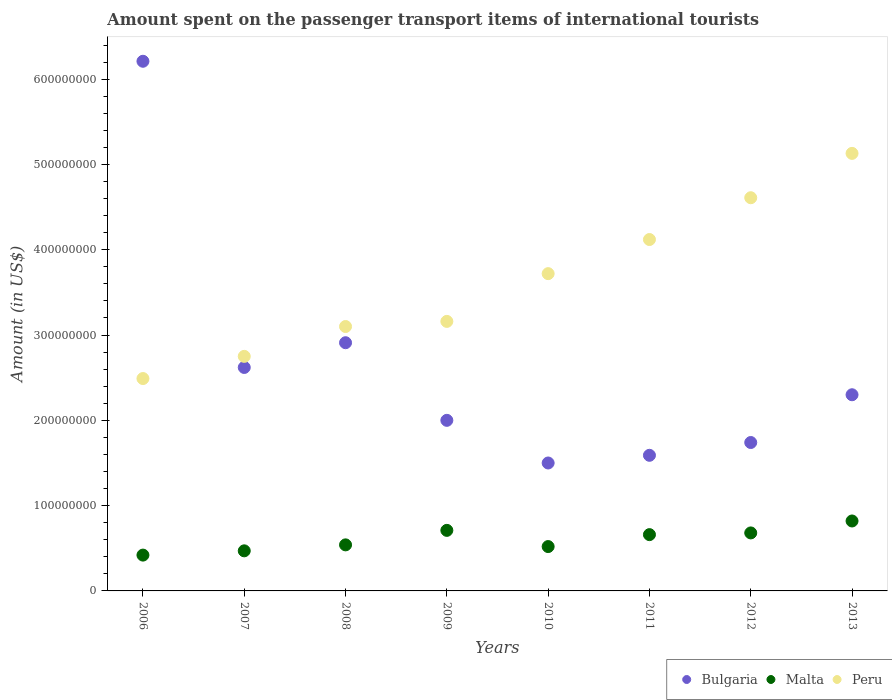How many different coloured dotlines are there?
Your answer should be very brief. 3. Is the number of dotlines equal to the number of legend labels?
Your response must be concise. Yes. What is the amount spent on the passenger transport items of international tourists in Malta in 2009?
Make the answer very short. 7.10e+07. Across all years, what is the maximum amount spent on the passenger transport items of international tourists in Bulgaria?
Give a very brief answer. 6.21e+08. Across all years, what is the minimum amount spent on the passenger transport items of international tourists in Bulgaria?
Offer a terse response. 1.50e+08. In which year was the amount spent on the passenger transport items of international tourists in Malta maximum?
Make the answer very short. 2013. In which year was the amount spent on the passenger transport items of international tourists in Bulgaria minimum?
Provide a succinct answer. 2010. What is the total amount spent on the passenger transport items of international tourists in Peru in the graph?
Provide a short and direct response. 2.91e+09. What is the difference between the amount spent on the passenger transport items of international tourists in Peru in 2007 and that in 2008?
Ensure brevity in your answer.  -3.50e+07. What is the difference between the amount spent on the passenger transport items of international tourists in Malta in 2009 and the amount spent on the passenger transport items of international tourists in Bulgaria in 2012?
Your response must be concise. -1.03e+08. What is the average amount spent on the passenger transport items of international tourists in Malta per year?
Give a very brief answer. 6.02e+07. In the year 2013, what is the difference between the amount spent on the passenger transport items of international tourists in Peru and amount spent on the passenger transport items of international tourists in Bulgaria?
Offer a very short reply. 2.83e+08. What is the ratio of the amount spent on the passenger transport items of international tourists in Peru in 2009 to that in 2013?
Provide a short and direct response. 0.62. Is the amount spent on the passenger transport items of international tourists in Malta in 2006 less than that in 2009?
Your answer should be very brief. Yes. Is the difference between the amount spent on the passenger transport items of international tourists in Peru in 2011 and 2012 greater than the difference between the amount spent on the passenger transport items of international tourists in Bulgaria in 2011 and 2012?
Your answer should be very brief. No. What is the difference between the highest and the second highest amount spent on the passenger transport items of international tourists in Bulgaria?
Your answer should be compact. 3.30e+08. What is the difference between the highest and the lowest amount spent on the passenger transport items of international tourists in Bulgaria?
Your answer should be very brief. 4.71e+08. Is the amount spent on the passenger transport items of international tourists in Malta strictly greater than the amount spent on the passenger transport items of international tourists in Peru over the years?
Your response must be concise. No. Is the amount spent on the passenger transport items of international tourists in Malta strictly less than the amount spent on the passenger transport items of international tourists in Bulgaria over the years?
Ensure brevity in your answer.  Yes. How many years are there in the graph?
Ensure brevity in your answer.  8. Are the values on the major ticks of Y-axis written in scientific E-notation?
Offer a very short reply. No. Does the graph contain any zero values?
Provide a succinct answer. No. Does the graph contain grids?
Offer a terse response. No. Where does the legend appear in the graph?
Your response must be concise. Bottom right. How are the legend labels stacked?
Provide a succinct answer. Horizontal. What is the title of the graph?
Ensure brevity in your answer.  Amount spent on the passenger transport items of international tourists. What is the label or title of the Y-axis?
Provide a short and direct response. Amount (in US$). What is the Amount (in US$) in Bulgaria in 2006?
Provide a succinct answer. 6.21e+08. What is the Amount (in US$) of Malta in 2006?
Provide a succinct answer. 4.20e+07. What is the Amount (in US$) in Peru in 2006?
Your answer should be compact. 2.49e+08. What is the Amount (in US$) in Bulgaria in 2007?
Keep it short and to the point. 2.62e+08. What is the Amount (in US$) in Malta in 2007?
Make the answer very short. 4.70e+07. What is the Amount (in US$) in Peru in 2007?
Provide a succinct answer. 2.75e+08. What is the Amount (in US$) of Bulgaria in 2008?
Your answer should be compact. 2.91e+08. What is the Amount (in US$) of Malta in 2008?
Give a very brief answer. 5.40e+07. What is the Amount (in US$) of Peru in 2008?
Your answer should be very brief. 3.10e+08. What is the Amount (in US$) in Malta in 2009?
Give a very brief answer. 7.10e+07. What is the Amount (in US$) of Peru in 2009?
Ensure brevity in your answer.  3.16e+08. What is the Amount (in US$) of Bulgaria in 2010?
Offer a terse response. 1.50e+08. What is the Amount (in US$) in Malta in 2010?
Offer a very short reply. 5.20e+07. What is the Amount (in US$) of Peru in 2010?
Provide a short and direct response. 3.72e+08. What is the Amount (in US$) in Bulgaria in 2011?
Keep it short and to the point. 1.59e+08. What is the Amount (in US$) of Malta in 2011?
Provide a short and direct response. 6.60e+07. What is the Amount (in US$) in Peru in 2011?
Offer a terse response. 4.12e+08. What is the Amount (in US$) in Bulgaria in 2012?
Provide a succinct answer. 1.74e+08. What is the Amount (in US$) of Malta in 2012?
Keep it short and to the point. 6.80e+07. What is the Amount (in US$) in Peru in 2012?
Provide a succinct answer. 4.61e+08. What is the Amount (in US$) of Bulgaria in 2013?
Keep it short and to the point. 2.30e+08. What is the Amount (in US$) in Malta in 2013?
Ensure brevity in your answer.  8.20e+07. What is the Amount (in US$) of Peru in 2013?
Your answer should be very brief. 5.13e+08. Across all years, what is the maximum Amount (in US$) of Bulgaria?
Keep it short and to the point. 6.21e+08. Across all years, what is the maximum Amount (in US$) of Malta?
Provide a short and direct response. 8.20e+07. Across all years, what is the maximum Amount (in US$) in Peru?
Ensure brevity in your answer.  5.13e+08. Across all years, what is the minimum Amount (in US$) in Bulgaria?
Make the answer very short. 1.50e+08. Across all years, what is the minimum Amount (in US$) of Malta?
Your answer should be compact. 4.20e+07. Across all years, what is the minimum Amount (in US$) of Peru?
Your response must be concise. 2.49e+08. What is the total Amount (in US$) of Bulgaria in the graph?
Offer a terse response. 2.09e+09. What is the total Amount (in US$) of Malta in the graph?
Offer a very short reply. 4.82e+08. What is the total Amount (in US$) in Peru in the graph?
Provide a short and direct response. 2.91e+09. What is the difference between the Amount (in US$) of Bulgaria in 2006 and that in 2007?
Offer a very short reply. 3.59e+08. What is the difference between the Amount (in US$) of Malta in 2006 and that in 2007?
Ensure brevity in your answer.  -5.00e+06. What is the difference between the Amount (in US$) of Peru in 2006 and that in 2007?
Give a very brief answer. -2.60e+07. What is the difference between the Amount (in US$) in Bulgaria in 2006 and that in 2008?
Make the answer very short. 3.30e+08. What is the difference between the Amount (in US$) in Malta in 2006 and that in 2008?
Make the answer very short. -1.20e+07. What is the difference between the Amount (in US$) in Peru in 2006 and that in 2008?
Ensure brevity in your answer.  -6.10e+07. What is the difference between the Amount (in US$) in Bulgaria in 2006 and that in 2009?
Provide a succinct answer. 4.21e+08. What is the difference between the Amount (in US$) in Malta in 2006 and that in 2009?
Keep it short and to the point. -2.90e+07. What is the difference between the Amount (in US$) in Peru in 2006 and that in 2009?
Your response must be concise. -6.70e+07. What is the difference between the Amount (in US$) in Bulgaria in 2006 and that in 2010?
Your answer should be very brief. 4.71e+08. What is the difference between the Amount (in US$) in Malta in 2006 and that in 2010?
Offer a very short reply. -1.00e+07. What is the difference between the Amount (in US$) of Peru in 2006 and that in 2010?
Provide a short and direct response. -1.23e+08. What is the difference between the Amount (in US$) in Bulgaria in 2006 and that in 2011?
Give a very brief answer. 4.62e+08. What is the difference between the Amount (in US$) of Malta in 2006 and that in 2011?
Keep it short and to the point. -2.40e+07. What is the difference between the Amount (in US$) of Peru in 2006 and that in 2011?
Offer a very short reply. -1.63e+08. What is the difference between the Amount (in US$) of Bulgaria in 2006 and that in 2012?
Offer a very short reply. 4.47e+08. What is the difference between the Amount (in US$) in Malta in 2006 and that in 2012?
Provide a succinct answer. -2.60e+07. What is the difference between the Amount (in US$) in Peru in 2006 and that in 2012?
Offer a terse response. -2.12e+08. What is the difference between the Amount (in US$) in Bulgaria in 2006 and that in 2013?
Keep it short and to the point. 3.91e+08. What is the difference between the Amount (in US$) in Malta in 2006 and that in 2013?
Your answer should be very brief. -4.00e+07. What is the difference between the Amount (in US$) of Peru in 2006 and that in 2013?
Provide a succinct answer. -2.64e+08. What is the difference between the Amount (in US$) of Bulgaria in 2007 and that in 2008?
Give a very brief answer. -2.90e+07. What is the difference between the Amount (in US$) in Malta in 2007 and that in 2008?
Your response must be concise. -7.00e+06. What is the difference between the Amount (in US$) of Peru in 2007 and that in 2008?
Make the answer very short. -3.50e+07. What is the difference between the Amount (in US$) of Bulgaria in 2007 and that in 2009?
Give a very brief answer. 6.20e+07. What is the difference between the Amount (in US$) of Malta in 2007 and that in 2009?
Provide a short and direct response. -2.40e+07. What is the difference between the Amount (in US$) in Peru in 2007 and that in 2009?
Ensure brevity in your answer.  -4.10e+07. What is the difference between the Amount (in US$) of Bulgaria in 2007 and that in 2010?
Keep it short and to the point. 1.12e+08. What is the difference between the Amount (in US$) in Malta in 2007 and that in 2010?
Provide a short and direct response. -5.00e+06. What is the difference between the Amount (in US$) of Peru in 2007 and that in 2010?
Give a very brief answer. -9.70e+07. What is the difference between the Amount (in US$) of Bulgaria in 2007 and that in 2011?
Give a very brief answer. 1.03e+08. What is the difference between the Amount (in US$) of Malta in 2007 and that in 2011?
Your response must be concise. -1.90e+07. What is the difference between the Amount (in US$) in Peru in 2007 and that in 2011?
Keep it short and to the point. -1.37e+08. What is the difference between the Amount (in US$) of Bulgaria in 2007 and that in 2012?
Provide a succinct answer. 8.80e+07. What is the difference between the Amount (in US$) in Malta in 2007 and that in 2012?
Your answer should be very brief. -2.10e+07. What is the difference between the Amount (in US$) in Peru in 2007 and that in 2012?
Make the answer very short. -1.86e+08. What is the difference between the Amount (in US$) in Bulgaria in 2007 and that in 2013?
Offer a very short reply. 3.20e+07. What is the difference between the Amount (in US$) in Malta in 2007 and that in 2013?
Keep it short and to the point. -3.50e+07. What is the difference between the Amount (in US$) in Peru in 2007 and that in 2013?
Keep it short and to the point. -2.38e+08. What is the difference between the Amount (in US$) in Bulgaria in 2008 and that in 2009?
Provide a succinct answer. 9.10e+07. What is the difference between the Amount (in US$) of Malta in 2008 and that in 2009?
Provide a succinct answer. -1.70e+07. What is the difference between the Amount (in US$) of Peru in 2008 and that in 2009?
Your answer should be compact. -6.00e+06. What is the difference between the Amount (in US$) in Bulgaria in 2008 and that in 2010?
Offer a very short reply. 1.41e+08. What is the difference between the Amount (in US$) in Malta in 2008 and that in 2010?
Your answer should be compact. 2.00e+06. What is the difference between the Amount (in US$) in Peru in 2008 and that in 2010?
Provide a short and direct response. -6.20e+07. What is the difference between the Amount (in US$) in Bulgaria in 2008 and that in 2011?
Make the answer very short. 1.32e+08. What is the difference between the Amount (in US$) in Malta in 2008 and that in 2011?
Your answer should be very brief. -1.20e+07. What is the difference between the Amount (in US$) in Peru in 2008 and that in 2011?
Make the answer very short. -1.02e+08. What is the difference between the Amount (in US$) in Bulgaria in 2008 and that in 2012?
Your response must be concise. 1.17e+08. What is the difference between the Amount (in US$) in Malta in 2008 and that in 2012?
Offer a terse response. -1.40e+07. What is the difference between the Amount (in US$) in Peru in 2008 and that in 2012?
Offer a very short reply. -1.51e+08. What is the difference between the Amount (in US$) in Bulgaria in 2008 and that in 2013?
Your answer should be very brief. 6.10e+07. What is the difference between the Amount (in US$) in Malta in 2008 and that in 2013?
Provide a succinct answer. -2.80e+07. What is the difference between the Amount (in US$) in Peru in 2008 and that in 2013?
Offer a terse response. -2.03e+08. What is the difference between the Amount (in US$) in Bulgaria in 2009 and that in 2010?
Ensure brevity in your answer.  5.00e+07. What is the difference between the Amount (in US$) of Malta in 2009 and that in 2010?
Provide a succinct answer. 1.90e+07. What is the difference between the Amount (in US$) of Peru in 2009 and that in 2010?
Keep it short and to the point. -5.60e+07. What is the difference between the Amount (in US$) of Bulgaria in 2009 and that in 2011?
Provide a succinct answer. 4.10e+07. What is the difference between the Amount (in US$) in Peru in 2009 and that in 2011?
Keep it short and to the point. -9.60e+07. What is the difference between the Amount (in US$) of Bulgaria in 2009 and that in 2012?
Your response must be concise. 2.60e+07. What is the difference between the Amount (in US$) in Malta in 2009 and that in 2012?
Give a very brief answer. 3.00e+06. What is the difference between the Amount (in US$) in Peru in 2009 and that in 2012?
Provide a short and direct response. -1.45e+08. What is the difference between the Amount (in US$) in Bulgaria in 2009 and that in 2013?
Offer a terse response. -3.00e+07. What is the difference between the Amount (in US$) in Malta in 2009 and that in 2013?
Your answer should be compact. -1.10e+07. What is the difference between the Amount (in US$) in Peru in 2009 and that in 2013?
Your answer should be very brief. -1.97e+08. What is the difference between the Amount (in US$) in Bulgaria in 2010 and that in 2011?
Keep it short and to the point. -9.00e+06. What is the difference between the Amount (in US$) of Malta in 2010 and that in 2011?
Your answer should be compact. -1.40e+07. What is the difference between the Amount (in US$) in Peru in 2010 and that in 2011?
Ensure brevity in your answer.  -4.00e+07. What is the difference between the Amount (in US$) of Bulgaria in 2010 and that in 2012?
Your answer should be very brief. -2.40e+07. What is the difference between the Amount (in US$) of Malta in 2010 and that in 2012?
Your answer should be very brief. -1.60e+07. What is the difference between the Amount (in US$) of Peru in 2010 and that in 2012?
Your answer should be very brief. -8.90e+07. What is the difference between the Amount (in US$) of Bulgaria in 2010 and that in 2013?
Give a very brief answer. -8.00e+07. What is the difference between the Amount (in US$) of Malta in 2010 and that in 2013?
Offer a very short reply. -3.00e+07. What is the difference between the Amount (in US$) in Peru in 2010 and that in 2013?
Make the answer very short. -1.41e+08. What is the difference between the Amount (in US$) of Bulgaria in 2011 and that in 2012?
Ensure brevity in your answer.  -1.50e+07. What is the difference between the Amount (in US$) in Peru in 2011 and that in 2012?
Make the answer very short. -4.90e+07. What is the difference between the Amount (in US$) in Bulgaria in 2011 and that in 2013?
Your answer should be very brief. -7.10e+07. What is the difference between the Amount (in US$) of Malta in 2011 and that in 2013?
Offer a very short reply. -1.60e+07. What is the difference between the Amount (in US$) of Peru in 2011 and that in 2013?
Offer a terse response. -1.01e+08. What is the difference between the Amount (in US$) of Bulgaria in 2012 and that in 2013?
Your answer should be compact. -5.60e+07. What is the difference between the Amount (in US$) of Malta in 2012 and that in 2013?
Give a very brief answer. -1.40e+07. What is the difference between the Amount (in US$) of Peru in 2012 and that in 2013?
Offer a very short reply. -5.20e+07. What is the difference between the Amount (in US$) of Bulgaria in 2006 and the Amount (in US$) of Malta in 2007?
Offer a terse response. 5.74e+08. What is the difference between the Amount (in US$) in Bulgaria in 2006 and the Amount (in US$) in Peru in 2007?
Provide a short and direct response. 3.46e+08. What is the difference between the Amount (in US$) in Malta in 2006 and the Amount (in US$) in Peru in 2007?
Your response must be concise. -2.33e+08. What is the difference between the Amount (in US$) of Bulgaria in 2006 and the Amount (in US$) of Malta in 2008?
Offer a very short reply. 5.67e+08. What is the difference between the Amount (in US$) in Bulgaria in 2006 and the Amount (in US$) in Peru in 2008?
Your response must be concise. 3.11e+08. What is the difference between the Amount (in US$) of Malta in 2006 and the Amount (in US$) of Peru in 2008?
Ensure brevity in your answer.  -2.68e+08. What is the difference between the Amount (in US$) in Bulgaria in 2006 and the Amount (in US$) in Malta in 2009?
Your answer should be compact. 5.50e+08. What is the difference between the Amount (in US$) in Bulgaria in 2006 and the Amount (in US$) in Peru in 2009?
Ensure brevity in your answer.  3.05e+08. What is the difference between the Amount (in US$) in Malta in 2006 and the Amount (in US$) in Peru in 2009?
Your answer should be very brief. -2.74e+08. What is the difference between the Amount (in US$) in Bulgaria in 2006 and the Amount (in US$) in Malta in 2010?
Offer a terse response. 5.69e+08. What is the difference between the Amount (in US$) in Bulgaria in 2006 and the Amount (in US$) in Peru in 2010?
Your answer should be compact. 2.49e+08. What is the difference between the Amount (in US$) of Malta in 2006 and the Amount (in US$) of Peru in 2010?
Offer a terse response. -3.30e+08. What is the difference between the Amount (in US$) in Bulgaria in 2006 and the Amount (in US$) in Malta in 2011?
Offer a very short reply. 5.55e+08. What is the difference between the Amount (in US$) of Bulgaria in 2006 and the Amount (in US$) of Peru in 2011?
Offer a terse response. 2.09e+08. What is the difference between the Amount (in US$) in Malta in 2006 and the Amount (in US$) in Peru in 2011?
Keep it short and to the point. -3.70e+08. What is the difference between the Amount (in US$) in Bulgaria in 2006 and the Amount (in US$) in Malta in 2012?
Ensure brevity in your answer.  5.53e+08. What is the difference between the Amount (in US$) in Bulgaria in 2006 and the Amount (in US$) in Peru in 2012?
Your answer should be compact. 1.60e+08. What is the difference between the Amount (in US$) in Malta in 2006 and the Amount (in US$) in Peru in 2012?
Keep it short and to the point. -4.19e+08. What is the difference between the Amount (in US$) in Bulgaria in 2006 and the Amount (in US$) in Malta in 2013?
Give a very brief answer. 5.39e+08. What is the difference between the Amount (in US$) in Bulgaria in 2006 and the Amount (in US$) in Peru in 2013?
Offer a very short reply. 1.08e+08. What is the difference between the Amount (in US$) in Malta in 2006 and the Amount (in US$) in Peru in 2013?
Your answer should be very brief. -4.71e+08. What is the difference between the Amount (in US$) in Bulgaria in 2007 and the Amount (in US$) in Malta in 2008?
Offer a very short reply. 2.08e+08. What is the difference between the Amount (in US$) of Bulgaria in 2007 and the Amount (in US$) of Peru in 2008?
Keep it short and to the point. -4.80e+07. What is the difference between the Amount (in US$) in Malta in 2007 and the Amount (in US$) in Peru in 2008?
Make the answer very short. -2.63e+08. What is the difference between the Amount (in US$) in Bulgaria in 2007 and the Amount (in US$) in Malta in 2009?
Give a very brief answer. 1.91e+08. What is the difference between the Amount (in US$) of Bulgaria in 2007 and the Amount (in US$) of Peru in 2009?
Give a very brief answer. -5.40e+07. What is the difference between the Amount (in US$) in Malta in 2007 and the Amount (in US$) in Peru in 2009?
Your response must be concise. -2.69e+08. What is the difference between the Amount (in US$) in Bulgaria in 2007 and the Amount (in US$) in Malta in 2010?
Keep it short and to the point. 2.10e+08. What is the difference between the Amount (in US$) in Bulgaria in 2007 and the Amount (in US$) in Peru in 2010?
Your answer should be compact. -1.10e+08. What is the difference between the Amount (in US$) of Malta in 2007 and the Amount (in US$) of Peru in 2010?
Your answer should be compact. -3.25e+08. What is the difference between the Amount (in US$) of Bulgaria in 2007 and the Amount (in US$) of Malta in 2011?
Offer a terse response. 1.96e+08. What is the difference between the Amount (in US$) in Bulgaria in 2007 and the Amount (in US$) in Peru in 2011?
Ensure brevity in your answer.  -1.50e+08. What is the difference between the Amount (in US$) of Malta in 2007 and the Amount (in US$) of Peru in 2011?
Give a very brief answer. -3.65e+08. What is the difference between the Amount (in US$) of Bulgaria in 2007 and the Amount (in US$) of Malta in 2012?
Your response must be concise. 1.94e+08. What is the difference between the Amount (in US$) in Bulgaria in 2007 and the Amount (in US$) in Peru in 2012?
Provide a succinct answer. -1.99e+08. What is the difference between the Amount (in US$) in Malta in 2007 and the Amount (in US$) in Peru in 2012?
Provide a succinct answer. -4.14e+08. What is the difference between the Amount (in US$) of Bulgaria in 2007 and the Amount (in US$) of Malta in 2013?
Ensure brevity in your answer.  1.80e+08. What is the difference between the Amount (in US$) in Bulgaria in 2007 and the Amount (in US$) in Peru in 2013?
Your response must be concise. -2.51e+08. What is the difference between the Amount (in US$) of Malta in 2007 and the Amount (in US$) of Peru in 2013?
Provide a succinct answer. -4.66e+08. What is the difference between the Amount (in US$) in Bulgaria in 2008 and the Amount (in US$) in Malta in 2009?
Ensure brevity in your answer.  2.20e+08. What is the difference between the Amount (in US$) in Bulgaria in 2008 and the Amount (in US$) in Peru in 2009?
Offer a terse response. -2.50e+07. What is the difference between the Amount (in US$) of Malta in 2008 and the Amount (in US$) of Peru in 2009?
Ensure brevity in your answer.  -2.62e+08. What is the difference between the Amount (in US$) of Bulgaria in 2008 and the Amount (in US$) of Malta in 2010?
Keep it short and to the point. 2.39e+08. What is the difference between the Amount (in US$) in Bulgaria in 2008 and the Amount (in US$) in Peru in 2010?
Your response must be concise. -8.10e+07. What is the difference between the Amount (in US$) in Malta in 2008 and the Amount (in US$) in Peru in 2010?
Keep it short and to the point. -3.18e+08. What is the difference between the Amount (in US$) in Bulgaria in 2008 and the Amount (in US$) in Malta in 2011?
Keep it short and to the point. 2.25e+08. What is the difference between the Amount (in US$) in Bulgaria in 2008 and the Amount (in US$) in Peru in 2011?
Your answer should be very brief. -1.21e+08. What is the difference between the Amount (in US$) of Malta in 2008 and the Amount (in US$) of Peru in 2011?
Provide a short and direct response. -3.58e+08. What is the difference between the Amount (in US$) of Bulgaria in 2008 and the Amount (in US$) of Malta in 2012?
Make the answer very short. 2.23e+08. What is the difference between the Amount (in US$) of Bulgaria in 2008 and the Amount (in US$) of Peru in 2012?
Your answer should be very brief. -1.70e+08. What is the difference between the Amount (in US$) in Malta in 2008 and the Amount (in US$) in Peru in 2012?
Make the answer very short. -4.07e+08. What is the difference between the Amount (in US$) of Bulgaria in 2008 and the Amount (in US$) of Malta in 2013?
Provide a short and direct response. 2.09e+08. What is the difference between the Amount (in US$) in Bulgaria in 2008 and the Amount (in US$) in Peru in 2013?
Ensure brevity in your answer.  -2.22e+08. What is the difference between the Amount (in US$) in Malta in 2008 and the Amount (in US$) in Peru in 2013?
Your answer should be very brief. -4.59e+08. What is the difference between the Amount (in US$) in Bulgaria in 2009 and the Amount (in US$) in Malta in 2010?
Provide a succinct answer. 1.48e+08. What is the difference between the Amount (in US$) in Bulgaria in 2009 and the Amount (in US$) in Peru in 2010?
Give a very brief answer. -1.72e+08. What is the difference between the Amount (in US$) in Malta in 2009 and the Amount (in US$) in Peru in 2010?
Offer a very short reply. -3.01e+08. What is the difference between the Amount (in US$) in Bulgaria in 2009 and the Amount (in US$) in Malta in 2011?
Your answer should be compact. 1.34e+08. What is the difference between the Amount (in US$) of Bulgaria in 2009 and the Amount (in US$) of Peru in 2011?
Offer a very short reply. -2.12e+08. What is the difference between the Amount (in US$) of Malta in 2009 and the Amount (in US$) of Peru in 2011?
Provide a short and direct response. -3.41e+08. What is the difference between the Amount (in US$) of Bulgaria in 2009 and the Amount (in US$) of Malta in 2012?
Keep it short and to the point. 1.32e+08. What is the difference between the Amount (in US$) in Bulgaria in 2009 and the Amount (in US$) in Peru in 2012?
Provide a succinct answer. -2.61e+08. What is the difference between the Amount (in US$) in Malta in 2009 and the Amount (in US$) in Peru in 2012?
Your answer should be very brief. -3.90e+08. What is the difference between the Amount (in US$) of Bulgaria in 2009 and the Amount (in US$) of Malta in 2013?
Provide a succinct answer. 1.18e+08. What is the difference between the Amount (in US$) in Bulgaria in 2009 and the Amount (in US$) in Peru in 2013?
Offer a terse response. -3.13e+08. What is the difference between the Amount (in US$) in Malta in 2009 and the Amount (in US$) in Peru in 2013?
Offer a terse response. -4.42e+08. What is the difference between the Amount (in US$) of Bulgaria in 2010 and the Amount (in US$) of Malta in 2011?
Your answer should be compact. 8.40e+07. What is the difference between the Amount (in US$) in Bulgaria in 2010 and the Amount (in US$) in Peru in 2011?
Ensure brevity in your answer.  -2.62e+08. What is the difference between the Amount (in US$) in Malta in 2010 and the Amount (in US$) in Peru in 2011?
Provide a succinct answer. -3.60e+08. What is the difference between the Amount (in US$) in Bulgaria in 2010 and the Amount (in US$) in Malta in 2012?
Ensure brevity in your answer.  8.20e+07. What is the difference between the Amount (in US$) in Bulgaria in 2010 and the Amount (in US$) in Peru in 2012?
Provide a succinct answer. -3.11e+08. What is the difference between the Amount (in US$) in Malta in 2010 and the Amount (in US$) in Peru in 2012?
Give a very brief answer. -4.09e+08. What is the difference between the Amount (in US$) in Bulgaria in 2010 and the Amount (in US$) in Malta in 2013?
Keep it short and to the point. 6.80e+07. What is the difference between the Amount (in US$) in Bulgaria in 2010 and the Amount (in US$) in Peru in 2013?
Provide a short and direct response. -3.63e+08. What is the difference between the Amount (in US$) in Malta in 2010 and the Amount (in US$) in Peru in 2013?
Give a very brief answer. -4.61e+08. What is the difference between the Amount (in US$) in Bulgaria in 2011 and the Amount (in US$) in Malta in 2012?
Provide a succinct answer. 9.10e+07. What is the difference between the Amount (in US$) in Bulgaria in 2011 and the Amount (in US$) in Peru in 2012?
Offer a terse response. -3.02e+08. What is the difference between the Amount (in US$) in Malta in 2011 and the Amount (in US$) in Peru in 2012?
Provide a short and direct response. -3.95e+08. What is the difference between the Amount (in US$) in Bulgaria in 2011 and the Amount (in US$) in Malta in 2013?
Your response must be concise. 7.70e+07. What is the difference between the Amount (in US$) in Bulgaria in 2011 and the Amount (in US$) in Peru in 2013?
Keep it short and to the point. -3.54e+08. What is the difference between the Amount (in US$) in Malta in 2011 and the Amount (in US$) in Peru in 2013?
Keep it short and to the point. -4.47e+08. What is the difference between the Amount (in US$) in Bulgaria in 2012 and the Amount (in US$) in Malta in 2013?
Your response must be concise. 9.20e+07. What is the difference between the Amount (in US$) in Bulgaria in 2012 and the Amount (in US$) in Peru in 2013?
Provide a short and direct response. -3.39e+08. What is the difference between the Amount (in US$) of Malta in 2012 and the Amount (in US$) of Peru in 2013?
Your answer should be compact. -4.45e+08. What is the average Amount (in US$) of Bulgaria per year?
Give a very brief answer. 2.61e+08. What is the average Amount (in US$) of Malta per year?
Make the answer very short. 6.02e+07. What is the average Amount (in US$) of Peru per year?
Provide a short and direct response. 3.64e+08. In the year 2006, what is the difference between the Amount (in US$) in Bulgaria and Amount (in US$) in Malta?
Provide a short and direct response. 5.79e+08. In the year 2006, what is the difference between the Amount (in US$) in Bulgaria and Amount (in US$) in Peru?
Keep it short and to the point. 3.72e+08. In the year 2006, what is the difference between the Amount (in US$) of Malta and Amount (in US$) of Peru?
Offer a terse response. -2.07e+08. In the year 2007, what is the difference between the Amount (in US$) in Bulgaria and Amount (in US$) in Malta?
Give a very brief answer. 2.15e+08. In the year 2007, what is the difference between the Amount (in US$) of Bulgaria and Amount (in US$) of Peru?
Your answer should be very brief. -1.30e+07. In the year 2007, what is the difference between the Amount (in US$) in Malta and Amount (in US$) in Peru?
Your answer should be very brief. -2.28e+08. In the year 2008, what is the difference between the Amount (in US$) in Bulgaria and Amount (in US$) in Malta?
Offer a very short reply. 2.37e+08. In the year 2008, what is the difference between the Amount (in US$) in Bulgaria and Amount (in US$) in Peru?
Your answer should be compact. -1.90e+07. In the year 2008, what is the difference between the Amount (in US$) of Malta and Amount (in US$) of Peru?
Offer a very short reply. -2.56e+08. In the year 2009, what is the difference between the Amount (in US$) of Bulgaria and Amount (in US$) of Malta?
Give a very brief answer. 1.29e+08. In the year 2009, what is the difference between the Amount (in US$) of Bulgaria and Amount (in US$) of Peru?
Keep it short and to the point. -1.16e+08. In the year 2009, what is the difference between the Amount (in US$) of Malta and Amount (in US$) of Peru?
Give a very brief answer. -2.45e+08. In the year 2010, what is the difference between the Amount (in US$) in Bulgaria and Amount (in US$) in Malta?
Keep it short and to the point. 9.80e+07. In the year 2010, what is the difference between the Amount (in US$) of Bulgaria and Amount (in US$) of Peru?
Provide a succinct answer. -2.22e+08. In the year 2010, what is the difference between the Amount (in US$) of Malta and Amount (in US$) of Peru?
Make the answer very short. -3.20e+08. In the year 2011, what is the difference between the Amount (in US$) of Bulgaria and Amount (in US$) of Malta?
Ensure brevity in your answer.  9.30e+07. In the year 2011, what is the difference between the Amount (in US$) of Bulgaria and Amount (in US$) of Peru?
Provide a short and direct response. -2.53e+08. In the year 2011, what is the difference between the Amount (in US$) in Malta and Amount (in US$) in Peru?
Provide a short and direct response. -3.46e+08. In the year 2012, what is the difference between the Amount (in US$) of Bulgaria and Amount (in US$) of Malta?
Your response must be concise. 1.06e+08. In the year 2012, what is the difference between the Amount (in US$) of Bulgaria and Amount (in US$) of Peru?
Provide a short and direct response. -2.87e+08. In the year 2012, what is the difference between the Amount (in US$) of Malta and Amount (in US$) of Peru?
Provide a succinct answer. -3.93e+08. In the year 2013, what is the difference between the Amount (in US$) of Bulgaria and Amount (in US$) of Malta?
Your answer should be compact. 1.48e+08. In the year 2013, what is the difference between the Amount (in US$) in Bulgaria and Amount (in US$) in Peru?
Keep it short and to the point. -2.83e+08. In the year 2013, what is the difference between the Amount (in US$) in Malta and Amount (in US$) in Peru?
Your response must be concise. -4.31e+08. What is the ratio of the Amount (in US$) in Bulgaria in 2006 to that in 2007?
Ensure brevity in your answer.  2.37. What is the ratio of the Amount (in US$) of Malta in 2006 to that in 2007?
Ensure brevity in your answer.  0.89. What is the ratio of the Amount (in US$) in Peru in 2006 to that in 2007?
Offer a very short reply. 0.91. What is the ratio of the Amount (in US$) in Bulgaria in 2006 to that in 2008?
Your answer should be very brief. 2.13. What is the ratio of the Amount (in US$) of Malta in 2006 to that in 2008?
Offer a very short reply. 0.78. What is the ratio of the Amount (in US$) of Peru in 2006 to that in 2008?
Give a very brief answer. 0.8. What is the ratio of the Amount (in US$) of Bulgaria in 2006 to that in 2009?
Make the answer very short. 3.1. What is the ratio of the Amount (in US$) of Malta in 2006 to that in 2009?
Give a very brief answer. 0.59. What is the ratio of the Amount (in US$) in Peru in 2006 to that in 2009?
Provide a short and direct response. 0.79. What is the ratio of the Amount (in US$) of Bulgaria in 2006 to that in 2010?
Your answer should be compact. 4.14. What is the ratio of the Amount (in US$) of Malta in 2006 to that in 2010?
Your response must be concise. 0.81. What is the ratio of the Amount (in US$) in Peru in 2006 to that in 2010?
Keep it short and to the point. 0.67. What is the ratio of the Amount (in US$) in Bulgaria in 2006 to that in 2011?
Your answer should be compact. 3.91. What is the ratio of the Amount (in US$) in Malta in 2006 to that in 2011?
Your response must be concise. 0.64. What is the ratio of the Amount (in US$) in Peru in 2006 to that in 2011?
Your answer should be very brief. 0.6. What is the ratio of the Amount (in US$) of Bulgaria in 2006 to that in 2012?
Provide a short and direct response. 3.57. What is the ratio of the Amount (in US$) in Malta in 2006 to that in 2012?
Provide a short and direct response. 0.62. What is the ratio of the Amount (in US$) in Peru in 2006 to that in 2012?
Provide a short and direct response. 0.54. What is the ratio of the Amount (in US$) in Bulgaria in 2006 to that in 2013?
Provide a short and direct response. 2.7. What is the ratio of the Amount (in US$) of Malta in 2006 to that in 2013?
Keep it short and to the point. 0.51. What is the ratio of the Amount (in US$) of Peru in 2006 to that in 2013?
Ensure brevity in your answer.  0.49. What is the ratio of the Amount (in US$) of Bulgaria in 2007 to that in 2008?
Offer a terse response. 0.9. What is the ratio of the Amount (in US$) of Malta in 2007 to that in 2008?
Offer a terse response. 0.87. What is the ratio of the Amount (in US$) of Peru in 2007 to that in 2008?
Make the answer very short. 0.89. What is the ratio of the Amount (in US$) in Bulgaria in 2007 to that in 2009?
Offer a terse response. 1.31. What is the ratio of the Amount (in US$) of Malta in 2007 to that in 2009?
Make the answer very short. 0.66. What is the ratio of the Amount (in US$) in Peru in 2007 to that in 2009?
Offer a terse response. 0.87. What is the ratio of the Amount (in US$) in Bulgaria in 2007 to that in 2010?
Your answer should be compact. 1.75. What is the ratio of the Amount (in US$) of Malta in 2007 to that in 2010?
Your answer should be very brief. 0.9. What is the ratio of the Amount (in US$) in Peru in 2007 to that in 2010?
Give a very brief answer. 0.74. What is the ratio of the Amount (in US$) in Bulgaria in 2007 to that in 2011?
Give a very brief answer. 1.65. What is the ratio of the Amount (in US$) of Malta in 2007 to that in 2011?
Your answer should be very brief. 0.71. What is the ratio of the Amount (in US$) in Peru in 2007 to that in 2011?
Your answer should be compact. 0.67. What is the ratio of the Amount (in US$) of Bulgaria in 2007 to that in 2012?
Offer a very short reply. 1.51. What is the ratio of the Amount (in US$) of Malta in 2007 to that in 2012?
Offer a terse response. 0.69. What is the ratio of the Amount (in US$) in Peru in 2007 to that in 2012?
Offer a very short reply. 0.6. What is the ratio of the Amount (in US$) of Bulgaria in 2007 to that in 2013?
Ensure brevity in your answer.  1.14. What is the ratio of the Amount (in US$) of Malta in 2007 to that in 2013?
Offer a very short reply. 0.57. What is the ratio of the Amount (in US$) of Peru in 2007 to that in 2013?
Your response must be concise. 0.54. What is the ratio of the Amount (in US$) in Bulgaria in 2008 to that in 2009?
Ensure brevity in your answer.  1.46. What is the ratio of the Amount (in US$) of Malta in 2008 to that in 2009?
Give a very brief answer. 0.76. What is the ratio of the Amount (in US$) in Peru in 2008 to that in 2009?
Keep it short and to the point. 0.98. What is the ratio of the Amount (in US$) in Bulgaria in 2008 to that in 2010?
Offer a terse response. 1.94. What is the ratio of the Amount (in US$) in Peru in 2008 to that in 2010?
Give a very brief answer. 0.83. What is the ratio of the Amount (in US$) of Bulgaria in 2008 to that in 2011?
Give a very brief answer. 1.83. What is the ratio of the Amount (in US$) of Malta in 2008 to that in 2011?
Your response must be concise. 0.82. What is the ratio of the Amount (in US$) of Peru in 2008 to that in 2011?
Ensure brevity in your answer.  0.75. What is the ratio of the Amount (in US$) in Bulgaria in 2008 to that in 2012?
Your answer should be compact. 1.67. What is the ratio of the Amount (in US$) of Malta in 2008 to that in 2012?
Ensure brevity in your answer.  0.79. What is the ratio of the Amount (in US$) of Peru in 2008 to that in 2012?
Keep it short and to the point. 0.67. What is the ratio of the Amount (in US$) of Bulgaria in 2008 to that in 2013?
Provide a short and direct response. 1.27. What is the ratio of the Amount (in US$) of Malta in 2008 to that in 2013?
Offer a terse response. 0.66. What is the ratio of the Amount (in US$) of Peru in 2008 to that in 2013?
Provide a succinct answer. 0.6. What is the ratio of the Amount (in US$) of Malta in 2009 to that in 2010?
Offer a terse response. 1.37. What is the ratio of the Amount (in US$) of Peru in 2009 to that in 2010?
Offer a terse response. 0.85. What is the ratio of the Amount (in US$) in Bulgaria in 2009 to that in 2011?
Offer a terse response. 1.26. What is the ratio of the Amount (in US$) in Malta in 2009 to that in 2011?
Keep it short and to the point. 1.08. What is the ratio of the Amount (in US$) of Peru in 2009 to that in 2011?
Provide a short and direct response. 0.77. What is the ratio of the Amount (in US$) of Bulgaria in 2009 to that in 2012?
Make the answer very short. 1.15. What is the ratio of the Amount (in US$) of Malta in 2009 to that in 2012?
Your response must be concise. 1.04. What is the ratio of the Amount (in US$) of Peru in 2009 to that in 2012?
Provide a succinct answer. 0.69. What is the ratio of the Amount (in US$) in Bulgaria in 2009 to that in 2013?
Give a very brief answer. 0.87. What is the ratio of the Amount (in US$) of Malta in 2009 to that in 2013?
Provide a succinct answer. 0.87. What is the ratio of the Amount (in US$) of Peru in 2009 to that in 2013?
Keep it short and to the point. 0.62. What is the ratio of the Amount (in US$) of Bulgaria in 2010 to that in 2011?
Your answer should be very brief. 0.94. What is the ratio of the Amount (in US$) in Malta in 2010 to that in 2011?
Keep it short and to the point. 0.79. What is the ratio of the Amount (in US$) of Peru in 2010 to that in 2011?
Your response must be concise. 0.9. What is the ratio of the Amount (in US$) of Bulgaria in 2010 to that in 2012?
Your response must be concise. 0.86. What is the ratio of the Amount (in US$) in Malta in 2010 to that in 2012?
Provide a short and direct response. 0.76. What is the ratio of the Amount (in US$) of Peru in 2010 to that in 2012?
Your answer should be compact. 0.81. What is the ratio of the Amount (in US$) in Bulgaria in 2010 to that in 2013?
Make the answer very short. 0.65. What is the ratio of the Amount (in US$) of Malta in 2010 to that in 2013?
Provide a short and direct response. 0.63. What is the ratio of the Amount (in US$) of Peru in 2010 to that in 2013?
Ensure brevity in your answer.  0.73. What is the ratio of the Amount (in US$) in Bulgaria in 2011 to that in 2012?
Your answer should be compact. 0.91. What is the ratio of the Amount (in US$) in Malta in 2011 to that in 2012?
Ensure brevity in your answer.  0.97. What is the ratio of the Amount (in US$) of Peru in 2011 to that in 2012?
Your response must be concise. 0.89. What is the ratio of the Amount (in US$) in Bulgaria in 2011 to that in 2013?
Keep it short and to the point. 0.69. What is the ratio of the Amount (in US$) of Malta in 2011 to that in 2013?
Keep it short and to the point. 0.8. What is the ratio of the Amount (in US$) in Peru in 2011 to that in 2013?
Give a very brief answer. 0.8. What is the ratio of the Amount (in US$) in Bulgaria in 2012 to that in 2013?
Make the answer very short. 0.76. What is the ratio of the Amount (in US$) in Malta in 2012 to that in 2013?
Ensure brevity in your answer.  0.83. What is the ratio of the Amount (in US$) of Peru in 2012 to that in 2013?
Give a very brief answer. 0.9. What is the difference between the highest and the second highest Amount (in US$) in Bulgaria?
Make the answer very short. 3.30e+08. What is the difference between the highest and the second highest Amount (in US$) of Malta?
Your answer should be compact. 1.10e+07. What is the difference between the highest and the second highest Amount (in US$) of Peru?
Make the answer very short. 5.20e+07. What is the difference between the highest and the lowest Amount (in US$) in Bulgaria?
Offer a terse response. 4.71e+08. What is the difference between the highest and the lowest Amount (in US$) in Malta?
Your answer should be compact. 4.00e+07. What is the difference between the highest and the lowest Amount (in US$) in Peru?
Offer a very short reply. 2.64e+08. 